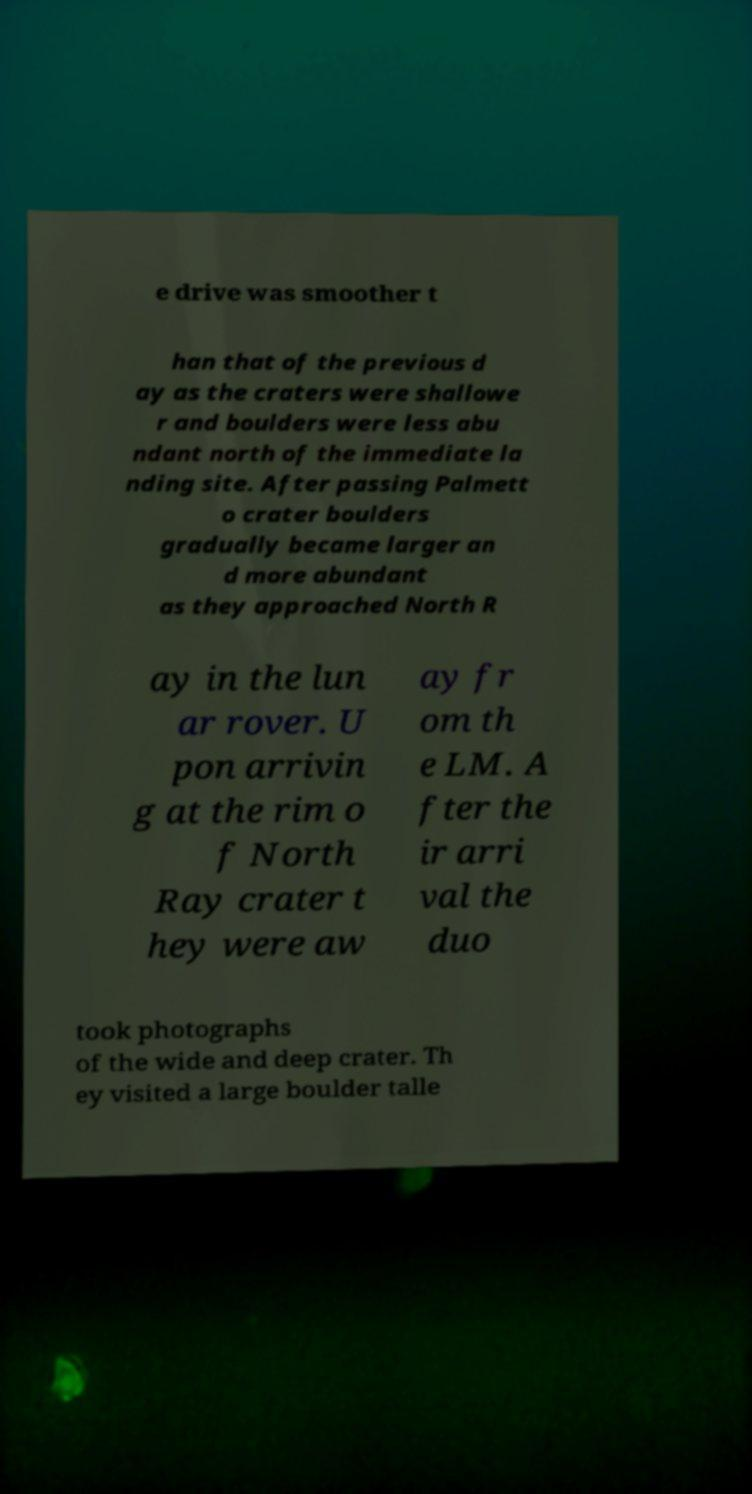For documentation purposes, I need the text within this image transcribed. Could you provide that? e drive was smoother t han that of the previous d ay as the craters were shallowe r and boulders were less abu ndant north of the immediate la nding site. After passing Palmett o crater boulders gradually became larger an d more abundant as they approached North R ay in the lun ar rover. U pon arrivin g at the rim o f North Ray crater t hey were aw ay fr om th e LM. A fter the ir arri val the duo took photographs of the wide and deep crater. Th ey visited a large boulder talle 